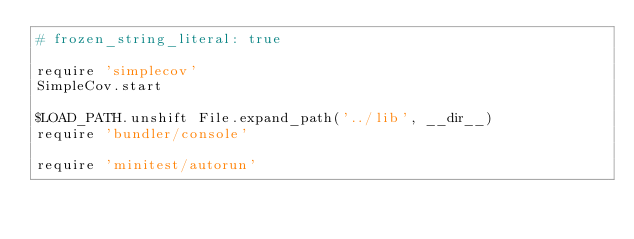<code> <loc_0><loc_0><loc_500><loc_500><_Ruby_># frozen_string_literal: true

require 'simplecov'
SimpleCov.start

$LOAD_PATH.unshift File.expand_path('../lib', __dir__)
require 'bundler/console'

require 'minitest/autorun'
</code> 